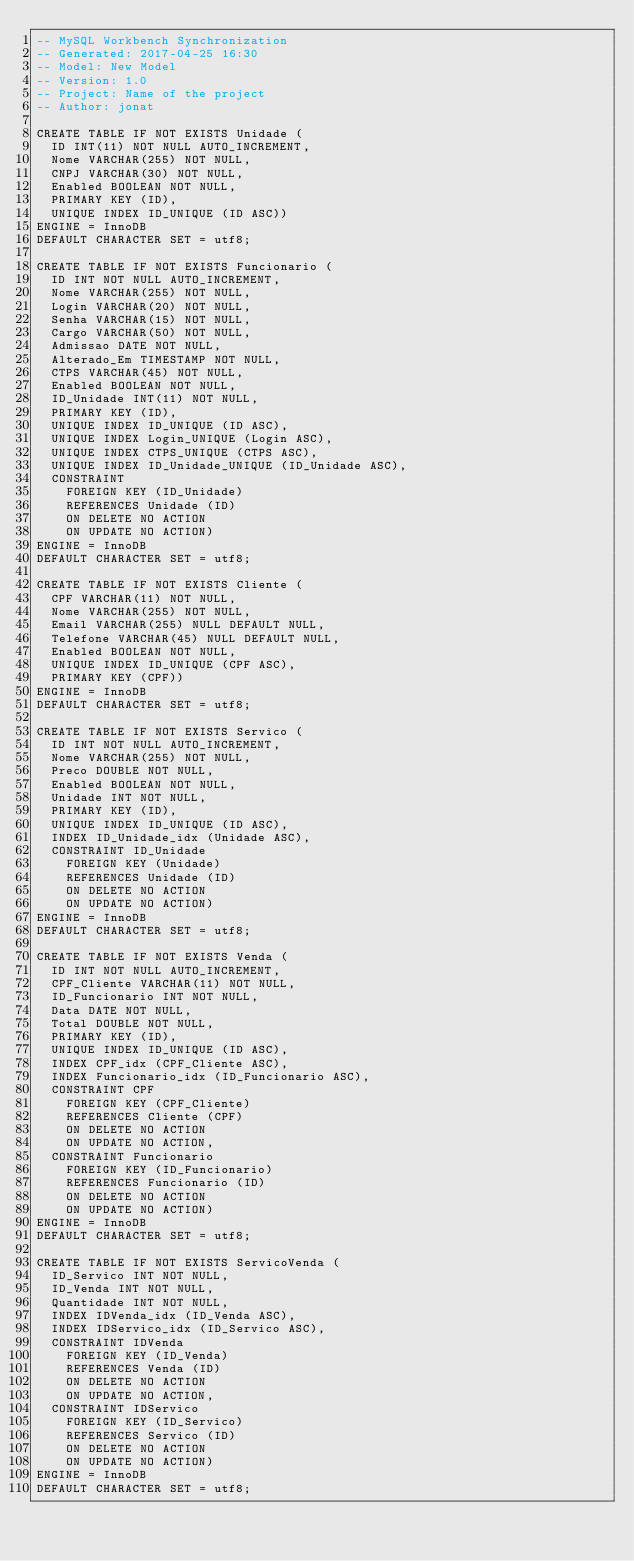Convert code to text. <code><loc_0><loc_0><loc_500><loc_500><_SQL_>-- MySQL Workbench Synchronization
-- Generated: 2017-04-25 16:30
-- Model: New Model
-- Version: 1.0
-- Project: Name of the project
-- Author: jonat

CREATE TABLE IF NOT EXISTS Unidade (
  ID INT(11) NOT NULL AUTO_INCREMENT,
  Nome VARCHAR(255) NOT NULL,
  CNPJ VARCHAR(30) NOT NULL,
  Enabled BOOLEAN NOT NULL,
  PRIMARY KEY (ID),
  UNIQUE INDEX ID_UNIQUE (ID ASC))
ENGINE = InnoDB
DEFAULT CHARACTER SET = utf8;

CREATE TABLE IF NOT EXISTS Funcionario (
  ID INT NOT NULL AUTO_INCREMENT,
  Nome VARCHAR(255) NOT NULL,
  Login VARCHAR(20) NOT NULL,
  Senha VARCHAR(15) NOT NULL,
  Cargo VARCHAR(50) NOT NULL,
  Admissao DATE NOT NULL,
  Alterado_Em TIMESTAMP NOT NULL,
  CTPS VARCHAR(45) NOT NULL,
  Enabled BOOLEAN NOT NULL,
  ID_Unidade INT(11) NOT NULL,
  PRIMARY KEY (ID),
  UNIQUE INDEX ID_UNIQUE (ID ASC),
  UNIQUE INDEX Login_UNIQUE (Login ASC),
  UNIQUE INDEX CTPS_UNIQUE (CTPS ASC),
  UNIQUE INDEX ID_Unidade_UNIQUE (ID_Unidade ASC),
  CONSTRAINT
    FOREIGN KEY (ID_Unidade)
    REFERENCES Unidade (ID)
    ON DELETE NO ACTION
    ON UPDATE NO ACTION)
ENGINE = InnoDB
DEFAULT CHARACTER SET = utf8;

CREATE TABLE IF NOT EXISTS Cliente (
  CPF VARCHAR(11) NOT NULL,
  Nome VARCHAR(255) NOT NULL,
  Email VARCHAR(255) NULL DEFAULT NULL,
  Telefone VARCHAR(45) NULL DEFAULT NULL,
  Enabled BOOLEAN NOT NULL,
  UNIQUE INDEX ID_UNIQUE (CPF ASC),
  PRIMARY KEY (CPF))
ENGINE = InnoDB
DEFAULT CHARACTER SET = utf8;

CREATE TABLE IF NOT EXISTS Servico (
  ID INT NOT NULL AUTO_INCREMENT,
  Nome VARCHAR(255) NOT NULL,
  Preco DOUBLE NOT NULL,
  Enabled BOOLEAN NOT NULL,
  Unidade INT NOT NULL,
  PRIMARY KEY (ID),
  UNIQUE INDEX ID_UNIQUE (ID ASC),
  INDEX ID_Unidade_idx (Unidade ASC),
  CONSTRAINT ID_Unidade
    FOREIGN KEY (Unidade)
    REFERENCES Unidade (ID)
    ON DELETE NO ACTION
    ON UPDATE NO ACTION)
ENGINE = InnoDB
DEFAULT CHARACTER SET = utf8;

CREATE TABLE IF NOT EXISTS Venda (
  ID INT NOT NULL AUTO_INCREMENT,
  CPF_Cliente VARCHAR(11) NOT NULL,
  ID_Funcionario INT NOT NULL,
  Data DATE NOT NULL,
  Total DOUBLE NOT NULL,
  PRIMARY KEY (ID),
  UNIQUE INDEX ID_UNIQUE (ID ASC),
  INDEX CPF_idx (CPF_Cliente ASC),
  INDEX Funcionario_idx (ID_Funcionario ASC),
  CONSTRAINT CPF
    FOREIGN KEY (CPF_Cliente)
    REFERENCES Cliente (CPF)
    ON DELETE NO ACTION
    ON UPDATE NO ACTION,
  CONSTRAINT Funcionario
    FOREIGN KEY (ID_Funcionario)
    REFERENCES Funcionario (ID)
    ON DELETE NO ACTION
    ON UPDATE NO ACTION)
ENGINE = InnoDB
DEFAULT CHARACTER SET = utf8;

CREATE TABLE IF NOT EXISTS ServicoVenda (
  ID_Servico INT NOT NULL,
  ID_Venda INT NOT NULL,
  Quantidade INT NOT NULL,
  INDEX IDVenda_idx (ID_Venda ASC),
  INDEX IDServico_idx (ID_Servico ASC),
  CONSTRAINT IDVenda
    FOREIGN KEY (ID_Venda)
    REFERENCES Venda (ID)
    ON DELETE NO ACTION
    ON UPDATE NO ACTION,
  CONSTRAINT IDServico
    FOREIGN KEY (ID_Servico)
    REFERENCES Servico (ID)
    ON DELETE NO ACTION
    ON UPDATE NO ACTION)
ENGINE = InnoDB
DEFAULT CHARACTER SET = utf8;

</code> 